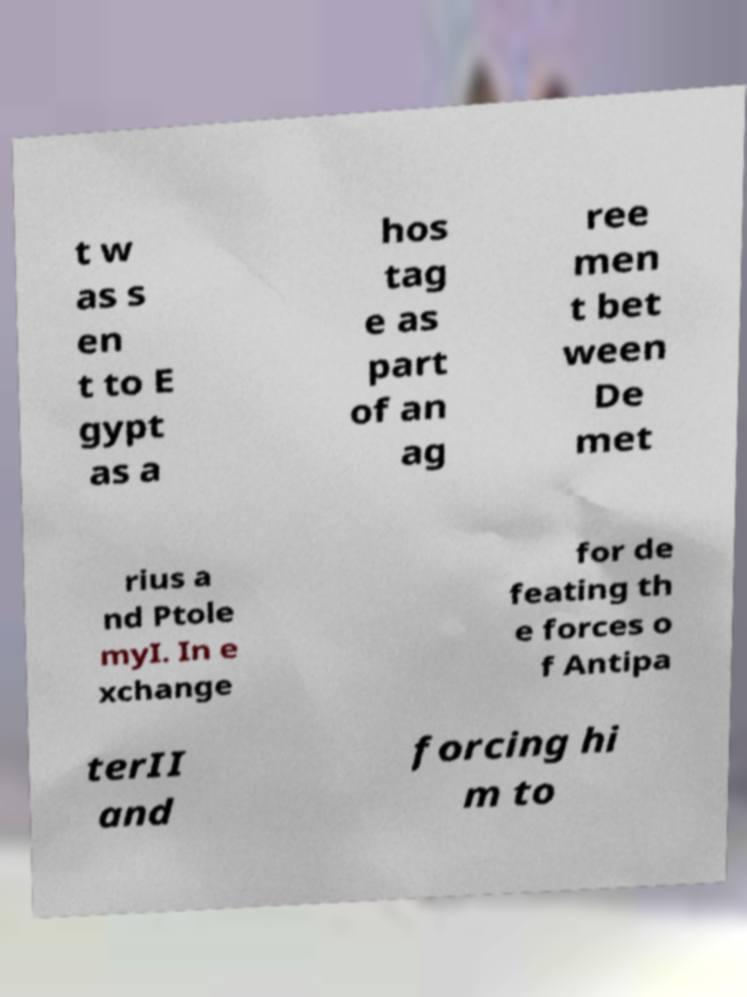Could you assist in decoding the text presented in this image and type it out clearly? t w as s en t to E gypt as a hos tag e as part of an ag ree men t bet ween De met rius a nd Ptole myI. In e xchange for de feating th e forces o f Antipa terII and forcing hi m to 